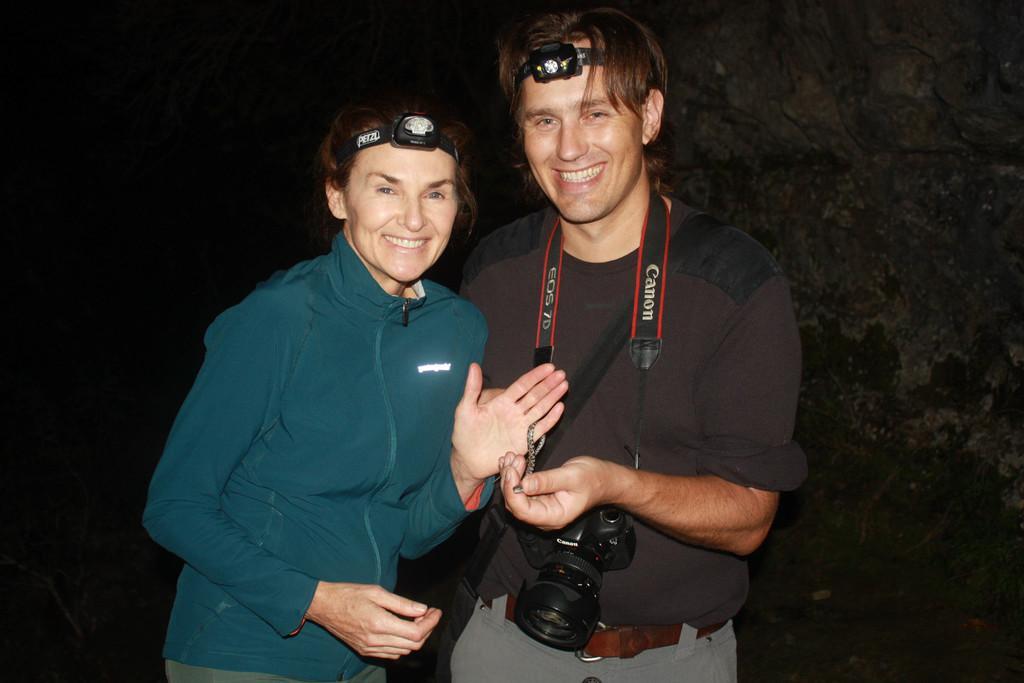In one or two sentences, can you explain what this image depicts? In this picture we can see two people smiling, holding a snake with their hands, headlamps on their heads and a man carrying a camera and in the background we can see a tree and it is dark. 